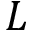Convert formula to latex. <formula><loc_0><loc_0><loc_500><loc_500>L</formula> 